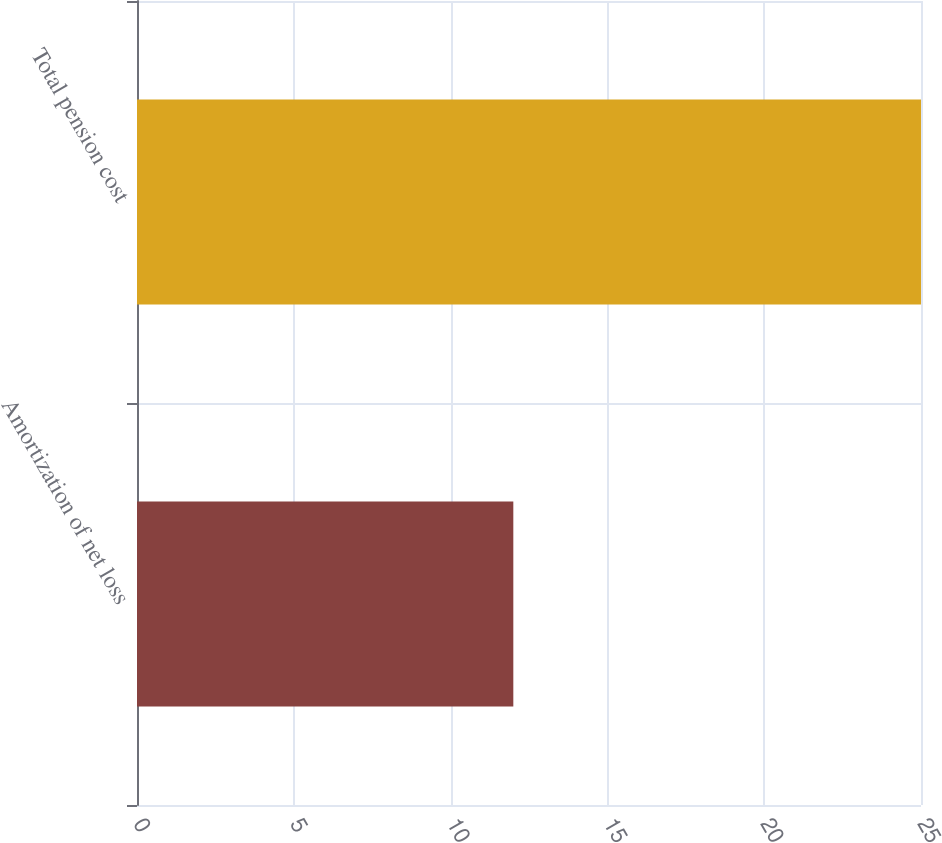Convert chart. <chart><loc_0><loc_0><loc_500><loc_500><bar_chart><fcel>Amortization of net loss<fcel>Total pension cost<nl><fcel>12<fcel>25<nl></chart> 